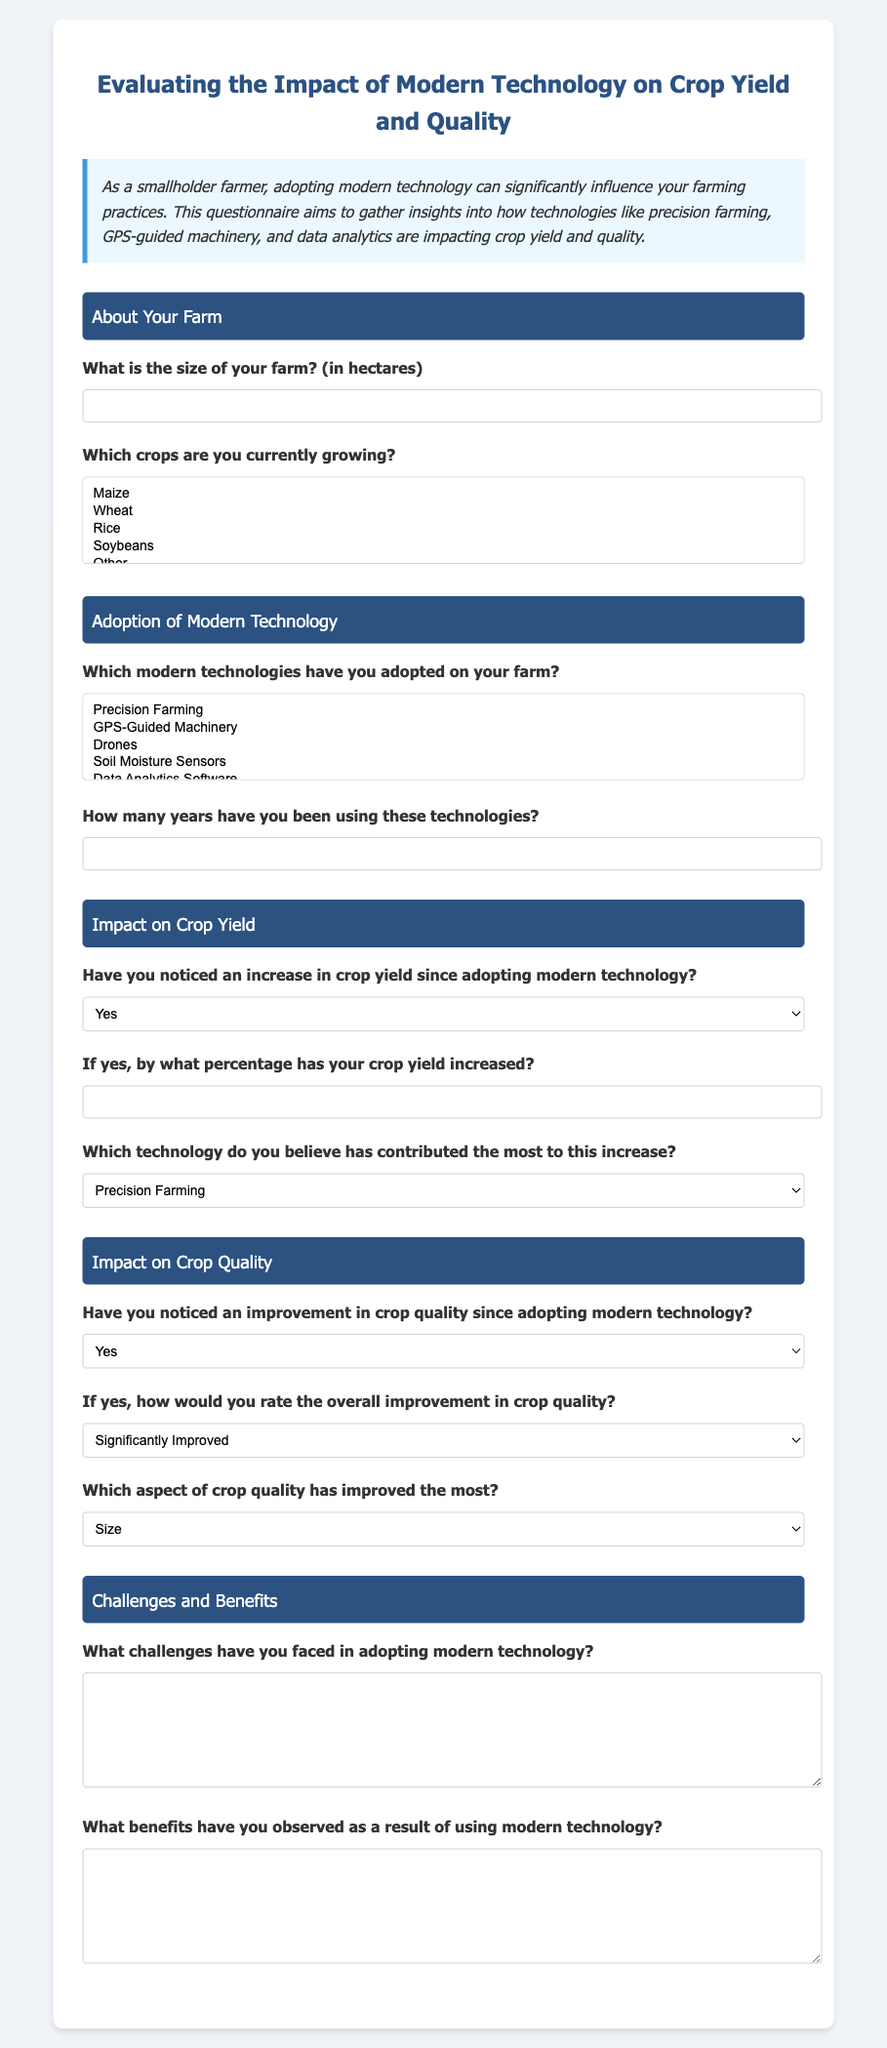What is the title of the questionnaire? The title, prominently displayed at the top of the document, summarizes the focus of the questionnaire.
Answer: Evaluating the Impact of Modern Technology on Crop Yield and Quality What crop is not listed in the options for crops currently being grown? The answer can be found in the options provided in the document for crops, identifying any that are missing.
Answer: Vegetables How many technologies can a respondent select in the "Adoption of Modern Technology" section? This is determined by the number of options available in the multiple-choice section for modern technologies adopted on the farm.
Answer: Multiple What is the maximum percentage a farmer can indicate for crop yield increase? The document specifies a range for the percentage options the farmer can select, determining any limits.
Answer: 100 What is the question asked regarding the improvement in crop quality? This is inferred from the options given in the "Impact on Crop Quality" section about noticing changes in quality.
Answer: Have you noticed an improvement in crop quality since adopting modern technology? What feedback is requested about challenges faced in adopting technology? This question pertains to the type of response the document seeks regarding the difficulties encountered.
Answer: Open-ended response What benefit is inquired about from the use of modern technology? The questionnaire seeks specific benefits reported by farmers from using modern technology in farming practices.
Answer: Open-ended response What kind of input is required for the farm size question? This question relates to the type of data that needs to be entered by respondents regarding their farm size.
Answer: Number (in hectares) How long is the specified time range for the use of technologies? This question looks for the format of the answer expected for the duration of technology use on the farm.
Answer: Number of years 